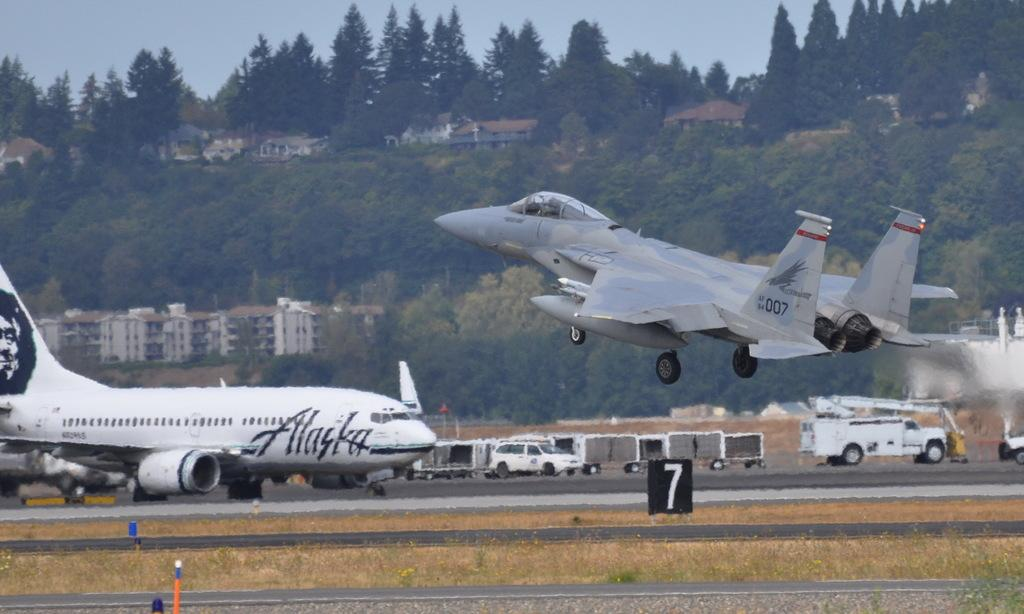<image>
Share a concise interpretation of the image provided. An Alaska Airline plane sits parked on a runway as a jet flies by a board with the number seven. 